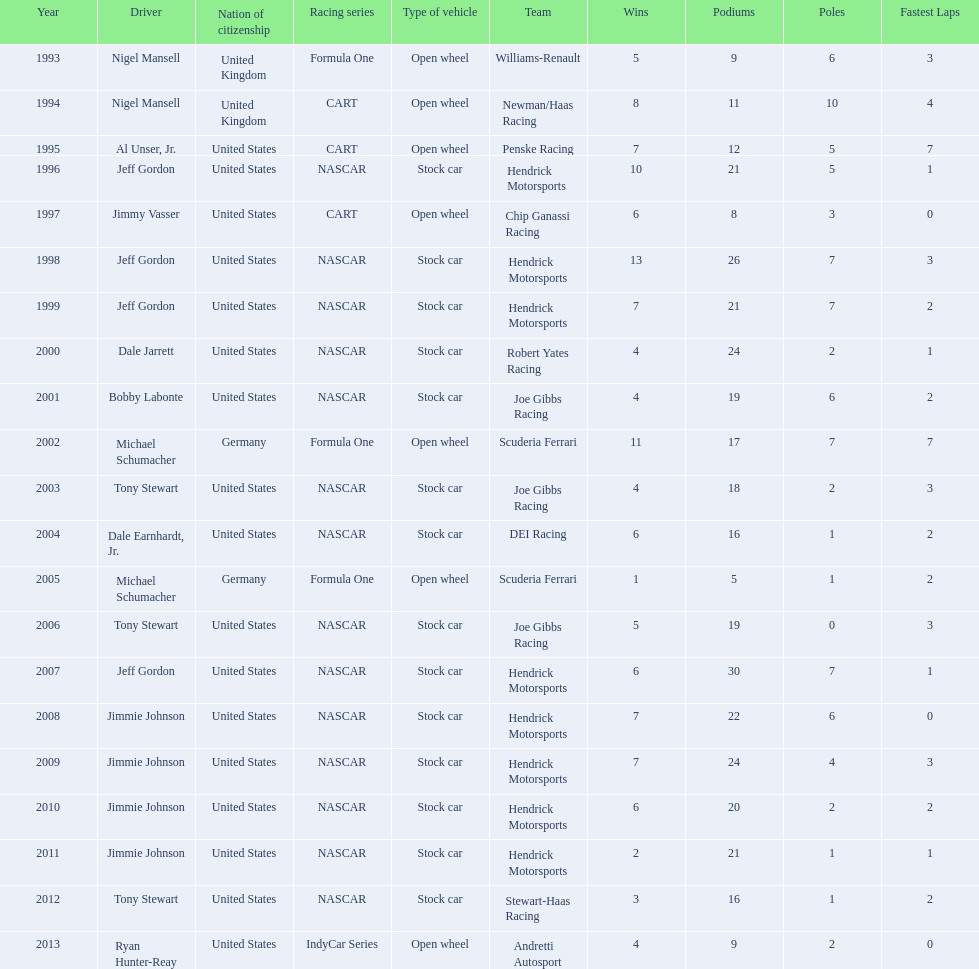Who won an espy in the year 2004, bobby labonte, tony stewart, dale earnhardt jr., or jeff gordon? Dale Earnhardt, Jr. Who won the espy in the year 1997; nigel mansell, al unser, jr., jeff gordon, or jimmy vasser? Jimmy Vasser. Which one only has one espy; nigel mansell, al unser jr., michael schumacher, or jeff gordon? Al Unser, Jr. 